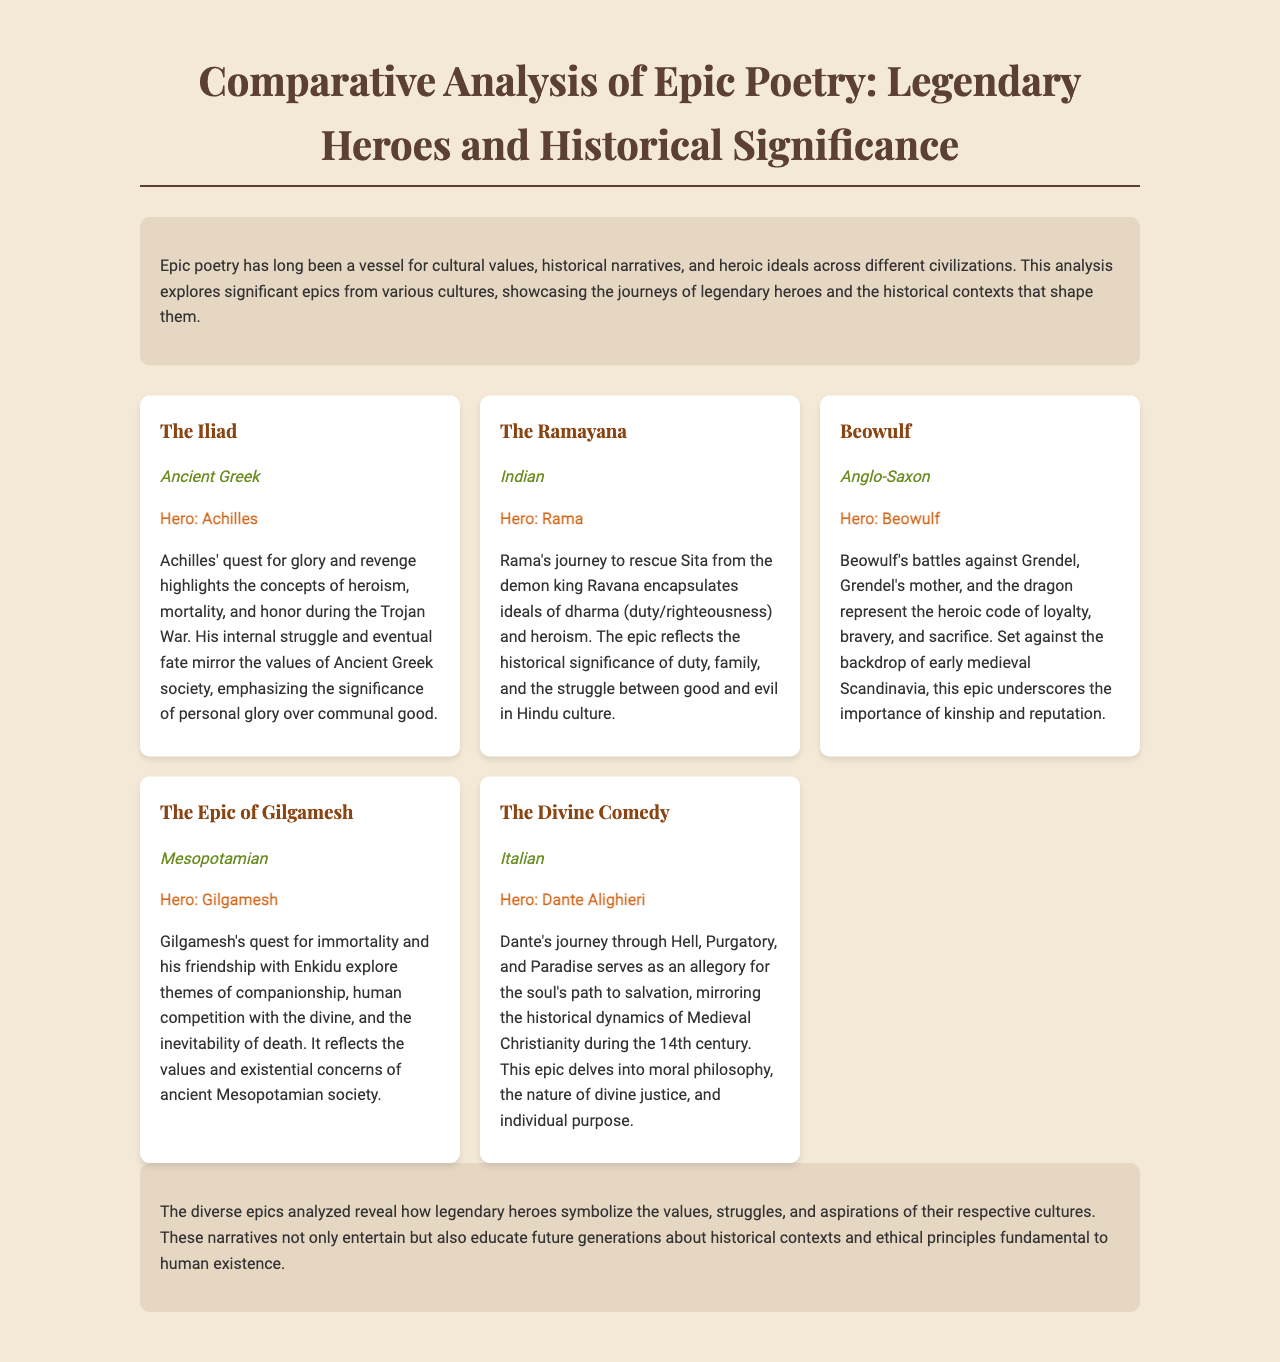What is the title of the document? The title is prominently displayed at the top of the document, indicating the subject matter.
Answer: Comparative Analysis of Epic Poetry: Legendary Heroes and Historical Significance Who is the hero of The Ramayana? The hero is mentioned in the section detailing that epic's significance and character.
Answer: Rama Which culture does Beowulf represent? This information is included in the description of the epic, specifying its cultural background.
Answer: Anglo-Saxon What theme does Gilgamesh's quest explore? The document highlights the themes associated with the journeys of the heroes, particularly in relation to Gilgamesh.
Answer: Companionship How many epics are analyzed in the document? The number of epics can be determined by counting the individual sections dedicated to each epic.
Answer: Five What significant journey does Dante undertake in The Divine Comedy? The journey is described in detail, focusing on its allegorical significance.
Answer: Hell, Purgatory, and Paradise What is a common quality highlighted among the heroes? The document emphasizes certain heroic qualities across different cultures, reflecting their values.
Answer: Heroism What historical period does The Divine Comedy reflect? The historical dynamics relevant to this epic are indicated in its description.
Answer: 14th century 